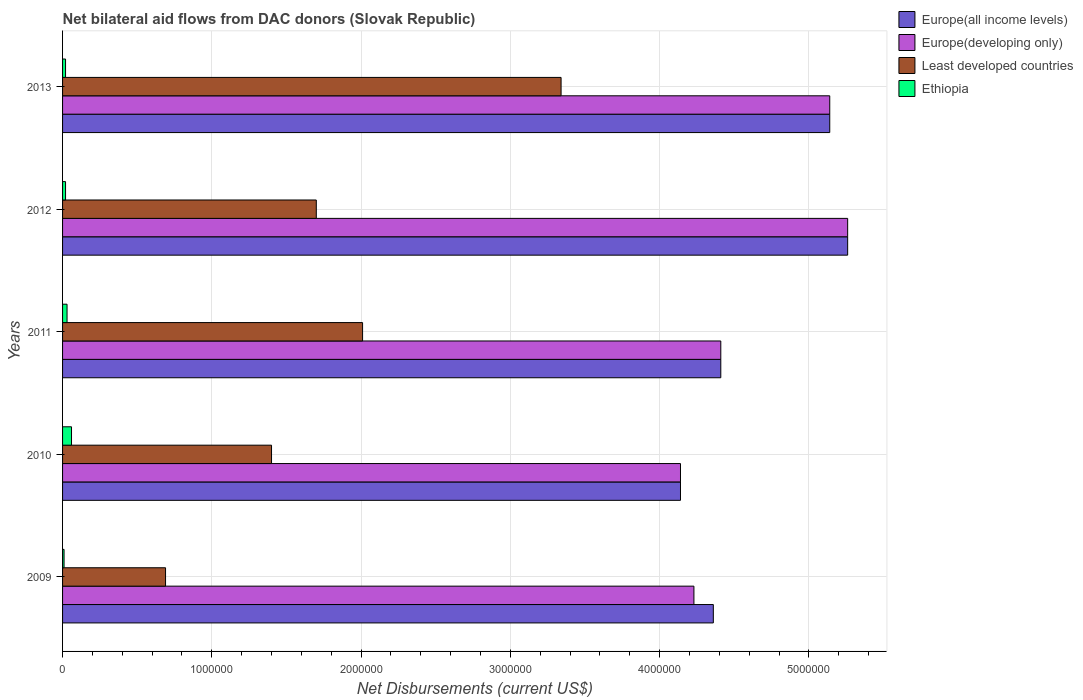How many groups of bars are there?
Provide a succinct answer. 5. What is the label of the 4th group of bars from the top?
Provide a succinct answer. 2010. In how many cases, is the number of bars for a given year not equal to the number of legend labels?
Provide a short and direct response. 0. What is the net bilateral aid flows in Europe(all income levels) in 2010?
Your answer should be compact. 4.14e+06. Across all years, what is the maximum net bilateral aid flows in Ethiopia?
Provide a succinct answer. 6.00e+04. Across all years, what is the minimum net bilateral aid flows in Europe(developing only)?
Your response must be concise. 4.14e+06. What is the total net bilateral aid flows in Europe(all income levels) in the graph?
Keep it short and to the point. 2.33e+07. What is the difference between the net bilateral aid flows in Least developed countries in 2010 and that in 2012?
Offer a very short reply. -3.00e+05. What is the difference between the net bilateral aid flows in Ethiopia in 2009 and the net bilateral aid flows in Europe(all income levels) in 2011?
Make the answer very short. -4.40e+06. What is the average net bilateral aid flows in Least developed countries per year?
Keep it short and to the point. 1.83e+06. In the year 2013, what is the difference between the net bilateral aid flows in Least developed countries and net bilateral aid flows in Ethiopia?
Keep it short and to the point. 3.32e+06. In how many years, is the net bilateral aid flows in Europe(developing only) greater than 2000000 US$?
Ensure brevity in your answer.  5. What is the ratio of the net bilateral aid flows in Europe(all income levels) in 2009 to that in 2012?
Your answer should be compact. 0.83. What is the difference between the highest and the second highest net bilateral aid flows in Europe(developing only)?
Ensure brevity in your answer.  1.20e+05. What is the difference between the highest and the lowest net bilateral aid flows in Least developed countries?
Provide a succinct answer. 2.65e+06. What does the 3rd bar from the top in 2012 represents?
Your response must be concise. Europe(developing only). What does the 3rd bar from the bottom in 2013 represents?
Make the answer very short. Least developed countries. How many bars are there?
Offer a very short reply. 20. Are all the bars in the graph horizontal?
Ensure brevity in your answer.  Yes. What is the difference between two consecutive major ticks on the X-axis?
Give a very brief answer. 1.00e+06. Are the values on the major ticks of X-axis written in scientific E-notation?
Provide a short and direct response. No. Does the graph contain any zero values?
Provide a short and direct response. No. Does the graph contain grids?
Your answer should be very brief. Yes. How many legend labels are there?
Offer a very short reply. 4. What is the title of the graph?
Your answer should be very brief. Net bilateral aid flows from DAC donors (Slovak Republic). Does "Zambia" appear as one of the legend labels in the graph?
Give a very brief answer. No. What is the label or title of the X-axis?
Ensure brevity in your answer.  Net Disbursements (current US$). What is the label or title of the Y-axis?
Provide a short and direct response. Years. What is the Net Disbursements (current US$) in Europe(all income levels) in 2009?
Make the answer very short. 4.36e+06. What is the Net Disbursements (current US$) in Europe(developing only) in 2009?
Make the answer very short. 4.23e+06. What is the Net Disbursements (current US$) of Least developed countries in 2009?
Your response must be concise. 6.90e+05. What is the Net Disbursements (current US$) in Ethiopia in 2009?
Provide a succinct answer. 10000. What is the Net Disbursements (current US$) of Europe(all income levels) in 2010?
Your response must be concise. 4.14e+06. What is the Net Disbursements (current US$) in Europe(developing only) in 2010?
Keep it short and to the point. 4.14e+06. What is the Net Disbursements (current US$) in Least developed countries in 2010?
Make the answer very short. 1.40e+06. What is the Net Disbursements (current US$) in Ethiopia in 2010?
Keep it short and to the point. 6.00e+04. What is the Net Disbursements (current US$) of Europe(all income levels) in 2011?
Offer a terse response. 4.41e+06. What is the Net Disbursements (current US$) in Europe(developing only) in 2011?
Offer a terse response. 4.41e+06. What is the Net Disbursements (current US$) in Least developed countries in 2011?
Keep it short and to the point. 2.01e+06. What is the Net Disbursements (current US$) in Europe(all income levels) in 2012?
Offer a terse response. 5.26e+06. What is the Net Disbursements (current US$) of Europe(developing only) in 2012?
Offer a very short reply. 5.26e+06. What is the Net Disbursements (current US$) in Least developed countries in 2012?
Give a very brief answer. 1.70e+06. What is the Net Disbursements (current US$) in Ethiopia in 2012?
Offer a terse response. 2.00e+04. What is the Net Disbursements (current US$) in Europe(all income levels) in 2013?
Offer a very short reply. 5.14e+06. What is the Net Disbursements (current US$) of Europe(developing only) in 2013?
Your answer should be very brief. 5.14e+06. What is the Net Disbursements (current US$) in Least developed countries in 2013?
Provide a succinct answer. 3.34e+06. What is the Net Disbursements (current US$) of Ethiopia in 2013?
Ensure brevity in your answer.  2.00e+04. Across all years, what is the maximum Net Disbursements (current US$) in Europe(all income levels)?
Ensure brevity in your answer.  5.26e+06. Across all years, what is the maximum Net Disbursements (current US$) of Europe(developing only)?
Your answer should be compact. 5.26e+06. Across all years, what is the maximum Net Disbursements (current US$) of Least developed countries?
Offer a terse response. 3.34e+06. Across all years, what is the maximum Net Disbursements (current US$) of Ethiopia?
Offer a very short reply. 6.00e+04. Across all years, what is the minimum Net Disbursements (current US$) of Europe(all income levels)?
Your response must be concise. 4.14e+06. Across all years, what is the minimum Net Disbursements (current US$) of Europe(developing only)?
Your answer should be very brief. 4.14e+06. Across all years, what is the minimum Net Disbursements (current US$) in Least developed countries?
Your answer should be very brief. 6.90e+05. Across all years, what is the minimum Net Disbursements (current US$) of Ethiopia?
Give a very brief answer. 10000. What is the total Net Disbursements (current US$) of Europe(all income levels) in the graph?
Provide a succinct answer. 2.33e+07. What is the total Net Disbursements (current US$) in Europe(developing only) in the graph?
Offer a very short reply. 2.32e+07. What is the total Net Disbursements (current US$) of Least developed countries in the graph?
Your answer should be compact. 9.14e+06. What is the difference between the Net Disbursements (current US$) of Least developed countries in 2009 and that in 2010?
Keep it short and to the point. -7.10e+05. What is the difference between the Net Disbursements (current US$) of Europe(all income levels) in 2009 and that in 2011?
Provide a succinct answer. -5.00e+04. What is the difference between the Net Disbursements (current US$) of Least developed countries in 2009 and that in 2011?
Keep it short and to the point. -1.32e+06. What is the difference between the Net Disbursements (current US$) in Europe(all income levels) in 2009 and that in 2012?
Offer a very short reply. -9.00e+05. What is the difference between the Net Disbursements (current US$) in Europe(developing only) in 2009 and that in 2012?
Keep it short and to the point. -1.03e+06. What is the difference between the Net Disbursements (current US$) in Least developed countries in 2009 and that in 2012?
Your answer should be compact. -1.01e+06. What is the difference between the Net Disbursements (current US$) of Europe(all income levels) in 2009 and that in 2013?
Provide a succinct answer. -7.80e+05. What is the difference between the Net Disbursements (current US$) of Europe(developing only) in 2009 and that in 2013?
Keep it short and to the point. -9.10e+05. What is the difference between the Net Disbursements (current US$) of Least developed countries in 2009 and that in 2013?
Make the answer very short. -2.65e+06. What is the difference between the Net Disbursements (current US$) in Ethiopia in 2009 and that in 2013?
Offer a terse response. -10000. What is the difference between the Net Disbursements (current US$) of Europe(developing only) in 2010 and that in 2011?
Give a very brief answer. -2.70e+05. What is the difference between the Net Disbursements (current US$) of Least developed countries in 2010 and that in 2011?
Offer a very short reply. -6.10e+05. What is the difference between the Net Disbursements (current US$) of Ethiopia in 2010 and that in 2011?
Make the answer very short. 3.00e+04. What is the difference between the Net Disbursements (current US$) in Europe(all income levels) in 2010 and that in 2012?
Provide a succinct answer. -1.12e+06. What is the difference between the Net Disbursements (current US$) in Europe(developing only) in 2010 and that in 2012?
Your answer should be compact. -1.12e+06. What is the difference between the Net Disbursements (current US$) of Europe(all income levels) in 2010 and that in 2013?
Keep it short and to the point. -1.00e+06. What is the difference between the Net Disbursements (current US$) of Europe(developing only) in 2010 and that in 2013?
Keep it short and to the point. -1.00e+06. What is the difference between the Net Disbursements (current US$) of Least developed countries in 2010 and that in 2013?
Make the answer very short. -1.94e+06. What is the difference between the Net Disbursements (current US$) of Europe(all income levels) in 2011 and that in 2012?
Offer a terse response. -8.50e+05. What is the difference between the Net Disbursements (current US$) in Europe(developing only) in 2011 and that in 2012?
Make the answer very short. -8.50e+05. What is the difference between the Net Disbursements (current US$) of Ethiopia in 2011 and that in 2012?
Make the answer very short. 10000. What is the difference between the Net Disbursements (current US$) of Europe(all income levels) in 2011 and that in 2013?
Provide a short and direct response. -7.30e+05. What is the difference between the Net Disbursements (current US$) of Europe(developing only) in 2011 and that in 2013?
Provide a succinct answer. -7.30e+05. What is the difference between the Net Disbursements (current US$) in Least developed countries in 2011 and that in 2013?
Offer a terse response. -1.33e+06. What is the difference between the Net Disbursements (current US$) of Ethiopia in 2011 and that in 2013?
Offer a terse response. 10000. What is the difference between the Net Disbursements (current US$) of Least developed countries in 2012 and that in 2013?
Keep it short and to the point. -1.64e+06. What is the difference between the Net Disbursements (current US$) of Europe(all income levels) in 2009 and the Net Disbursements (current US$) of Least developed countries in 2010?
Ensure brevity in your answer.  2.96e+06. What is the difference between the Net Disbursements (current US$) of Europe(all income levels) in 2009 and the Net Disbursements (current US$) of Ethiopia in 2010?
Offer a terse response. 4.30e+06. What is the difference between the Net Disbursements (current US$) of Europe(developing only) in 2009 and the Net Disbursements (current US$) of Least developed countries in 2010?
Your answer should be very brief. 2.83e+06. What is the difference between the Net Disbursements (current US$) of Europe(developing only) in 2009 and the Net Disbursements (current US$) of Ethiopia in 2010?
Ensure brevity in your answer.  4.17e+06. What is the difference between the Net Disbursements (current US$) of Least developed countries in 2009 and the Net Disbursements (current US$) of Ethiopia in 2010?
Keep it short and to the point. 6.30e+05. What is the difference between the Net Disbursements (current US$) in Europe(all income levels) in 2009 and the Net Disbursements (current US$) in Europe(developing only) in 2011?
Offer a terse response. -5.00e+04. What is the difference between the Net Disbursements (current US$) in Europe(all income levels) in 2009 and the Net Disbursements (current US$) in Least developed countries in 2011?
Provide a short and direct response. 2.35e+06. What is the difference between the Net Disbursements (current US$) of Europe(all income levels) in 2009 and the Net Disbursements (current US$) of Ethiopia in 2011?
Your response must be concise. 4.33e+06. What is the difference between the Net Disbursements (current US$) of Europe(developing only) in 2009 and the Net Disbursements (current US$) of Least developed countries in 2011?
Offer a very short reply. 2.22e+06. What is the difference between the Net Disbursements (current US$) of Europe(developing only) in 2009 and the Net Disbursements (current US$) of Ethiopia in 2011?
Provide a succinct answer. 4.20e+06. What is the difference between the Net Disbursements (current US$) in Least developed countries in 2009 and the Net Disbursements (current US$) in Ethiopia in 2011?
Provide a succinct answer. 6.60e+05. What is the difference between the Net Disbursements (current US$) of Europe(all income levels) in 2009 and the Net Disbursements (current US$) of Europe(developing only) in 2012?
Give a very brief answer. -9.00e+05. What is the difference between the Net Disbursements (current US$) of Europe(all income levels) in 2009 and the Net Disbursements (current US$) of Least developed countries in 2012?
Give a very brief answer. 2.66e+06. What is the difference between the Net Disbursements (current US$) of Europe(all income levels) in 2009 and the Net Disbursements (current US$) of Ethiopia in 2012?
Your answer should be very brief. 4.34e+06. What is the difference between the Net Disbursements (current US$) of Europe(developing only) in 2009 and the Net Disbursements (current US$) of Least developed countries in 2012?
Your answer should be compact. 2.53e+06. What is the difference between the Net Disbursements (current US$) in Europe(developing only) in 2009 and the Net Disbursements (current US$) in Ethiopia in 2012?
Offer a terse response. 4.21e+06. What is the difference between the Net Disbursements (current US$) of Least developed countries in 2009 and the Net Disbursements (current US$) of Ethiopia in 2012?
Make the answer very short. 6.70e+05. What is the difference between the Net Disbursements (current US$) in Europe(all income levels) in 2009 and the Net Disbursements (current US$) in Europe(developing only) in 2013?
Offer a terse response. -7.80e+05. What is the difference between the Net Disbursements (current US$) of Europe(all income levels) in 2009 and the Net Disbursements (current US$) of Least developed countries in 2013?
Ensure brevity in your answer.  1.02e+06. What is the difference between the Net Disbursements (current US$) in Europe(all income levels) in 2009 and the Net Disbursements (current US$) in Ethiopia in 2013?
Your response must be concise. 4.34e+06. What is the difference between the Net Disbursements (current US$) in Europe(developing only) in 2009 and the Net Disbursements (current US$) in Least developed countries in 2013?
Offer a terse response. 8.90e+05. What is the difference between the Net Disbursements (current US$) of Europe(developing only) in 2009 and the Net Disbursements (current US$) of Ethiopia in 2013?
Ensure brevity in your answer.  4.21e+06. What is the difference between the Net Disbursements (current US$) in Least developed countries in 2009 and the Net Disbursements (current US$) in Ethiopia in 2013?
Give a very brief answer. 6.70e+05. What is the difference between the Net Disbursements (current US$) in Europe(all income levels) in 2010 and the Net Disbursements (current US$) in Europe(developing only) in 2011?
Make the answer very short. -2.70e+05. What is the difference between the Net Disbursements (current US$) in Europe(all income levels) in 2010 and the Net Disbursements (current US$) in Least developed countries in 2011?
Offer a terse response. 2.13e+06. What is the difference between the Net Disbursements (current US$) in Europe(all income levels) in 2010 and the Net Disbursements (current US$) in Ethiopia in 2011?
Provide a short and direct response. 4.11e+06. What is the difference between the Net Disbursements (current US$) in Europe(developing only) in 2010 and the Net Disbursements (current US$) in Least developed countries in 2011?
Your answer should be compact. 2.13e+06. What is the difference between the Net Disbursements (current US$) of Europe(developing only) in 2010 and the Net Disbursements (current US$) of Ethiopia in 2011?
Keep it short and to the point. 4.11e+06. What is the difference between the Net Disbursements (current US$) of Least developed countries in 2010 and the Net Disbursements (current US$) of Ethiopia in 2011?
Offer a very short reply. 1.37e+06. What is the difference between the Net Disbursements (current US$) of Europe(all income levels) in 2010 and the Net Disbursements (current US$) of Europe(developing only) in 2012?
Offer a terse response. -1.12e+06. What is the difference between the Net Disbursements (current US$) of Europe(all income levels) in 2010 and the Net Disbursements (current US$) of Least developed countries in 2012?
Ensure brevity in your answer.  2.44e+06. What is the difference between the Net Disbursements (current US$) in Europe(all income levels) in 2010 and the Net Disbursements (current US$) in Ethiopia in 2012?
Keep it short and to the point. 4.12e+06. What is the difference between the Net Disbursements (current US$) in Europe(developing only) in 2010 and the Net Disbursements (current US$) in Least developed countries in 2012?
Make the answer very short. 2.44e+06. What is the difference between the Net Disbursements (current US$) of Europe(developing only) in 2010 and the Net Disbursements (current US$) of Ethiopia in 2012?
Offer a very short reply. 4.12e+06. What is the difference between the Net Disbursements (current US$) of Least developed countries in 2010 and the Net Disbursements (current US$) of Ethiopia in 2012?
Your answer should be compact. 1.38e+06. What is the difference between the Net Disbursements (current US$) in Europe(all income levels) in 2010 and the Net Disbursements (current US$) in Europe(developing only) in 2013?
Make the answer very short. -1.00e+06. What is the difference between the Net Disbursements (current US$) of Europe(all income levels) in 2010 and the Net Disbursements (current US$) of Ethiopia in 2013?
Your response must be concise. 4.12e+06. What is the difference between the Net Disbursements (current US$) of Europe(developing only) in 2010 and the Net Disbursements (current US$) of Least developed countries in 2013?
Offer a very short reply. 8.00e+05. What is the difference between the Net Disbursements (current US$) in Europe(developing only) in 2010 and the Net Disbursements (current US$) in Ethiopia in 2013?
Keep it short and to the point. 4.12e+06. What is the difference between the Net Disbursements (current US$) in Least developed countries in 2010 and the Net Disbursements (current US$) in Ethiopia in 2013?
Your response must be concise. 1.38e+06. What is the difference between the Net Disbursements (current US$) of Europe(all income levels) in 2011 and the Net Disbursements (current US$) of Europe(developing only) in 2012?
Provide a succinct answer. -8.50e+05. What is the difference between the Net Disbursements (current US$) in Europe(all income levels) in 2011 and the Net Disbursements (current US$) in Least developed countries in 2012?
Your response must be concise. 2.71e+06. What is the difference between the Net Disbursements (current US$) in Europe(all income levels) in 2011 and the Net Disbursements (current US$) in Ethiopia in 2012?
Your response must be concise. 4.39e+06. What is the difference between the Net Disbursements (current US$) in Europe(developing only) in 2011 and the Net Disbursements (current US$) in Least developed countries in 2012?
Provide a succinct answer. 2.71e+06. What is the difference between the Net Disbursements (current US$) in Europe(developing only) in 2011 and the Net Disbursements (current US$) in Ethiopia in 2012?
Offer a very short reply. 4.39e+06. What is the difference between the Net Disbursements (current US$) of Least developed countries in 2011 and the Net Disbursements (current US$) of Ethiopia in 2012?
Offer a very short reply. 1.99e+06. What is the difference between the Net Disbursements (current US$) of Europe(all income levels) in 2011 and the Net Disbursements (current US$) of Europe(developing only) in 2013?
Offer a very short reply. -7.30e+05. What is the difference between the Net Disbursements (current US$) of Europe(all income levels) in 2011 and the Net Disbursements (current US$) of Least developed countries in 2013?
Your response must be concise. 1.07e+06. What is the difference between the Net Disbursements (current US$) of Europe(all income levels) in 2011 and the Net Disbursements (current US$) of Ethiopia in 2013?
Offer a terse response. 4.39e+06. What is the difference between the Net Disbursements (current US$) of Europe(developing only) in 2011 and the Net Disbursements (current US$) of Least developed countries in 2013?
Provide a short and direct response. 1.07e+06. What is the difference between the Net Disbursements (current US$) of Europe(developing only) in 2011 and the Net Disbursements (current US$) of Ethiopia in 2013?
Make the answer very short. 4.39e+06. What is the difference between the Net Disbursements (current US$) in Least developed countries in 2011 and the Net Disbursements (current US$) in Ethiopia in 2013?
Make the answer very short. 1.99e+06. What is the difference between the Net Disbursements (current US$) in Europe(all income levels) in 2012 and the Net Disbursements (current US$) in Europe(developing only) in 2013?
Your response must be concise. 1.20e+05. What is the difference between the Net Disbursements (current US$) of Europe(all income levels) in 2012 and the Net Disbursements (current US$) of Least developed countries in 2013?
Keep it short and to the point. 1.92e+06. What is the difference between the Net Disbursements (current US$) of Europe(all income levels) in 2012 and the Net Disbursements (current US$) of Ethiopia in 2013?
Your response must be concise. 5.24e+06. What is the difference between the Net Disbursements (current US$) of Europe(developing only) in 2012 and the Net Disbursements (current US$) of Least developed countries in 2013?
Offer a terse response. 1.92e+06. What is the difference between the Net Disbursements (current US$) in Europe(developing only) in 2012 and the Net Disbursements (current US$) in Ethiopia in 2013?
Offer a terse response. 5.24e+06. What is the difference between the Net Disbursements (current US$) in Least developed countries in 2012 and the Net Disbursements (current US$) in Ethiopia in 2013?
Offer a very short reply. 1.68e+06. What is the average Net Disbursements (current US$) of Europe(all income levels) per year?
Your response must be concise. 4.66e+06. What is the average Net Disbursements (current US$) of Europe(developing only) per year?
Your answer should be very brief. 4.64e+06. What is the average Net Disbursements (current US$) in Least developed countries per year?
Give a very brief answer. 1.83e+06. What is the average Net Disbursements (current US$) in Ethiopia per year?
Your answer should be compact. 2.80e+04. In the year 2009, what is the difference between the Net Disbursements (current US$) of Europe(all income levels) and Net Disbursements (current US$) of Europe(developing only)?
Provide a succinct answer. 1.30e+05. In the year 2009, what is the difference between the Net Disbursements (current US$) in Europe(all income levels) and Net Disbursements (current US$) in Least developed countries?
Offer a very short reply. 3.67e+06. In the year 2009, what is the difference between the Net Disbursements (current US$) of Europe(all income levels) and Net Disbursements (current US$) of Ethiopia?
Ensure brevity in your answer.  4.35e+06. In the year 2009, what is the difference between the Net Disbursements (current US$) of Europe(developing only) and Net Disbursements (current US$) of Least developed countries?
Offer a terse response. 3.54e+06. In the year 2009, what is the difference between the Net Disbursements (current US$) in Europe(developing only) and Net Disbursements (current US$) in Ethiopia?
Your answer should be very brief. 4.22e+06. In the year 2009, what is the difference between the Net Disbursements (current US$) of Least developed countries and Net Disbursements (current US$) of Ethiopia?
Offer a terse response. 6.80e+05. In the year 2010, what is the difference between the Net Disbursements (current US$) in Europe(all income levels) and Net Disbursements (current US$) in Europe(developing only)?
Keep it short and to the point. 0. In the year 2010, what is the difference between the Net Disbursements (current US$) of Europe(all income levels) and Net Disbursements (current US$) of Least developed countries?
Your answer should be very brief. 2.74e+06. In the year 2010, what is the difference between the Net Disbursements (current US$) of Europe(all income levels) and Net Disbursements (current US$) of Ethiopia?
Your answer should be very brief. 4.08e+06. In the year 2010, what is the difference between the Net Disbursements (current US$) of Europe(developing only) and Net Disbursements (current US$) of Least developed countries?
Provide a short and direct response. 2.74e+06. In the year 2010, what is the difference between the Net Disbursements (current US$) of Europe(developing only) and Net Disbursements (current US$) of Ethiopia?
Your answer should be compact. 4.08e+06. In the year 2010, what is the difference between the Net Disbursements (current US$) of Least developed countries and Net Disbursements (current US$) of Ethiopia?
Your response must be concise. 1.34e+06. In the year 2011, what is the difference between the Net Disbursements (current US$) in Europe(all income levels) and Net Disbursements (current US$) in Europe(developing only)?
Your response must be concise. 0. In the year 2011, what is the difference between the Net Disbursements (current US$) in Europe(all income levels) and Net Disbursements (current US$) in Least developed countries?
Your answer should be compact. 2.40e+06. In the year 2011, what is the difference between the Net Disbursements (current US$) of Europe(all income levels) and Net Disbursements (current US$) of Ethiopia?
Offer a very short reply. 4.38e+06. In the year 2011, what is the difference between the Net Disbursements (current US$) of Europe(developing only) and Net Disbursements (current US$) of Least developed countries?
Provide a succinct answer. 2.40e+06. In the year 2011, what is the difference between the Net Disbursements (current US$) of Europe(developing only) and Net Disbursements (current US$) of Ethiopia?
Your answer should be compact. 4.38e+06. In the year 2011, what is the difference between the Net Disbursements (current US$) of Least developed countries and Net Disbursements (current US$) of Ethiopia?
Offer a very short reply. 1.98e+06. In the year 2012, what is the difference between the Net Disbursements (current US$) of Europe(all income levels) and Net Disbursements (current US$) of Least developed countries?
Keep it short and to the point. 3.56e+06. In the year 2012, what is the difference between the Net Disbursements (current US$) of Europe(all income levels) and Net Disbursements (current US$) of Ethiopia?
Offer a very short reply. 5.24e+06. In the year 2012, what is the difference between the Net Disbursements (current US$) of Europe(developing only) and Net Disbursements (current US$) of Least developed countries?
Your response must be concise. 3.56e+06. In the year 2012, what is the difference between the Net Disbursements (current US$) of Europe(developing only) and Net Disbursements (current US$) of Ethiopia?
Your answer should be compact. 5.24e+06. In the year 2012, what is the difference between the Net Disbursements (current US$) of Least developed countries and Net Disbursements (current US$) of Ethiopia?
Offer a very short reply. 1.68e+06. In the year 2013, what is the difference between the Net Disbursements (current US$) in Europe(all income levels) and Net Disbursements (current US$) in Europe(developing only)?
Offer a terse response. 0. In the year 2013, what is the difference between the Net Disbursements (current US$) of Europe(all income levels) and Net Disbursements (current US$) of Least developed countries?
Keep it short and to the point. 1.80e+06. In the year 2013, what is the difference between the Net Disbursements (current US$) in Europe(all income levels) and Net Disbursements (current US$) in Ethiopia?
Keep it short and to the point. 5.12e+06. In the year 2013, what is the difference between the Net Disbursements (current US$) of Europe(developing only) and Net Disbursements (current US$) of Least developed countries?
Your answer should be very brief. 1.80e+06. In the year 2013, what is the difference between the Net Disbursements (current US$) of Europe(developing only) and Net Disbursements (current US$) of Ethiopia?
Your response must be concise. 5.12e+06. In the year 2013, what is the difference between the Net Disbursements (current US$) of Least developed countries and Net Disbursements (current US$) of Ethiopia?
Ensure brevity in your answer.  3.32e+06. What is the ratio of the Net Disbursements (current US$) of Europe(all income levels) in 2009 to that in 2010?
Make the answer very short. 1.05. What is the ratio of the Net Disbursements (current US$) in Europe(developing only) in 2009 to that in 2010?
Your answer should be compact. 1.02. What is the ratio of the Net Disbursements (current US$) of Least developed countries in 2009 to that in 2010?
Your response must be concise. 0.49. What is the ratio of the Net Disbursements (current US$) in Ethiopia in 2009 to that in 2010?
Your response must be concise. 0.17. What is the ratio of the Net Disbursements (current US$) in Europe(all income levels) in 2009 to that in 2011?
Provide a short and direct response. 0.99. What is the ratio of the Net Disbursements (current US$) in Europe(developing only) in 2009 to that in 2011?
Provide a short and direct response. 0.96. What is the ratio of the Net Disbursements (current US$) of Least developed countries in 2009 to that in 2011?
Your response must be concise. 0.34. What is the ratio of the Net Disbursements (current US$) of Ethiopia in 2009 to that in 2011?
Your answer should be compact. 0.33. What is the ratio of the Net Disbursements (current US$) in Europe(all income levels) in 2009 to that in 2012?
Provide a succinct answer. 0.83. What is the ratio of the Net Disbursements (current US$) in Europe(developing only) in 2009 to that in 2012?
Keep it short and to the point. 0.8. What is the ratio of the Net Disbursements (current US$) of Least developed countries in 2009 to that in 2012?
Give a very brief answer. 0.41. What is the ratio of the Net Disbursements (current US$) of Ethiopia in 2009 to that in 2012?
Make the answer very short. 0.5. What is the ratio of the Net Disbursements (current US$) in Europe(all income levels) in 2009 to that in 2013?
Provide a succinct answer. 0.85. What is the ratio of the Net Disbursements (current US$) in Europe(developing only) in 2009 to that in 2013?
Ensure brevity in your answer.  0.82. What is the ratio of the Net Disbursements (current US$) in Least developed countries in 2009 to that in 2013?
Offer a very short reply. 0.21. What is the ratio of the Net Disbursements (current US$) of Europe(all income levels) in 2010 to that in 2011?
Keep it short and to the point. 0.94. What is the ratio of the Net Disbursements (current US$) of Europe(developing only) in 2010 to that in 2011?
Offer a terse response. 0.94. What is the ratio of the Net Disbursements (current US$) in Least developed countries in 2010 to that in 2011?
Ensure brevity in your answer.  0.7. What is the ratio of the Net Disbursements (current US$) of Ethiopia in 2010 to that in 2011?
Give a very brief answer. 2. What is the ratio of the Net Disbursements (current US$) in Europe(all income levels) in 2010 to that in 2012?
Provide a succinct answer. 0.79. What is the ratio of the Net Disbursements (current US$) of Europe(developing only) in 2010 to that in 2012?
Your answer should be compact. 0.79. What is the ratio of the Net Disbursements (current US$) of Least developed countries in 2010 to that in 2012?
Provide a succinct answer. 0.82. What is the ratio of the Net Disbursements (current US$) of Europe(all income levels) in 2010 to that in 2013?
Offer a terse response. 0.81. What is the ratio of the Net Disbursements (current US$) of Europe(developing only) in 2010 to that in 2013?
Give a very brief answer. 0.81. What is the ratio of the Net Disbursements (current US$) in Least developed countries in 2010 to that in 2013?
Keep it short and to the point. 0.42. What is the ratio of the Net Disbursements (current US$) of Ethiopia in 2010 to that in 2013?
Provide a succinct answer. 3. What is the ratio of the Net Disbursements (current US$) in Europe(all income levels) in 2011 to that in 2012?
Your response must be concise. 0.84. What is the ratio of the Net Disbursements (current US$) in Europe(developing only) in 2011 to that in 2012?
Provide a succinct answer. 0.84. What is the ratio of the Net Disbursements (current US$) in Least developed countries in 2011 to that in 2012?
Make the answer very short. 1.18. What is the ratio of the Net Disbursements (current US$) of Europe(all income levels) in 2011 to that in 2013?
Offer a terse response. 0.86. What is the ratio of the Net Disbursements (current US$) in Europe(developing only) in 2011 to that in 2013?
Make the answer very short. 0.86. What is the ratio of the Net Disbursements (current US$) in Least developed countries in 2011 to that in 2013?
Make the answer very short. 0.6. What is the ratio of the Net Disbursements (current US$) of Ethiopia in 2011 to that in 2013?
Your response must be concise. 1.5. What is the ratio of the Net Disbursements (current US$) of Europe(all income levels) in 2012 to that in 2013?
Ensure brevity in your answer.  1.02. What is the ratio of the Net Disbursements (current US$) in Europe(developing only) in 2012 to that in 2013?
Provide a short and direct response. 1.02. What is the ratio of the Net Disbursements (current US$) of Least developed countries in 2012 to that in 2013?
Your response must be concise. 0.51. What is the ratio of the Net Disbursements (current US$) in Ethiopia in 2012 to that in 2013?
Ensure brevity in your answer.  1. What is the difference between the highest and the second highest Net Disbursements (current US$) in Europe(all income levels)?
Offer a very short reply. 1.20e+05. What is the difference between the highest and the second highest Net Disbursements (current US$) in Least developed countries?
Offer a terse response. 1.33e+06. What is the difference between the highest and the lowest Net Disbursements (current US$) of Europe(all income levels)?
Make the answer very short. 1.12e+06. What is the difference between the highest and the lowest Net Disbursements (current US$) in Europe(developing only)?
Ensure brevity in your answer.  1.12e+06. What is the difference between the highest and the lowest Net Disbursements (current US$) in Least developed countries?
Provide a succinct answer. 2.65e+06. 